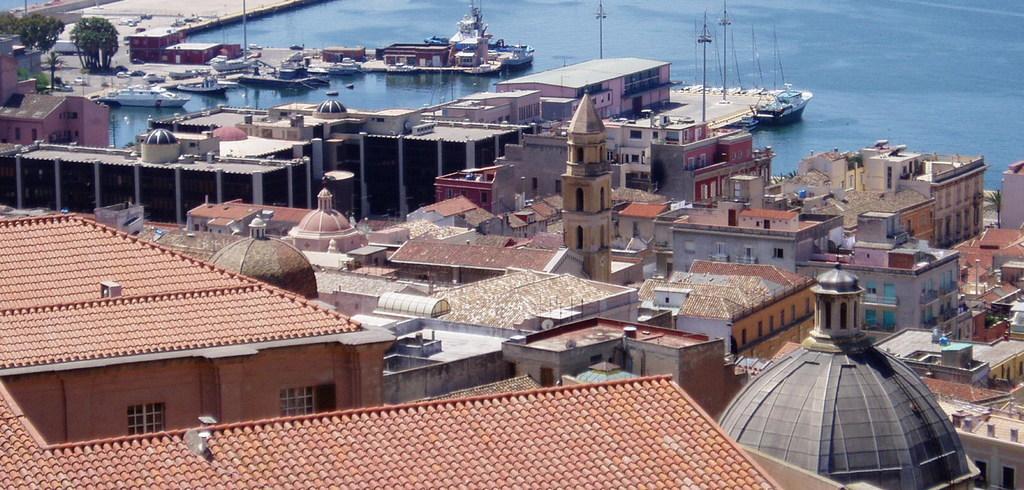In one or two sentences, can you explain what this image depicts? In this image in the front there are buildings. In the background there is water and there are ships on the water and there are trees. 